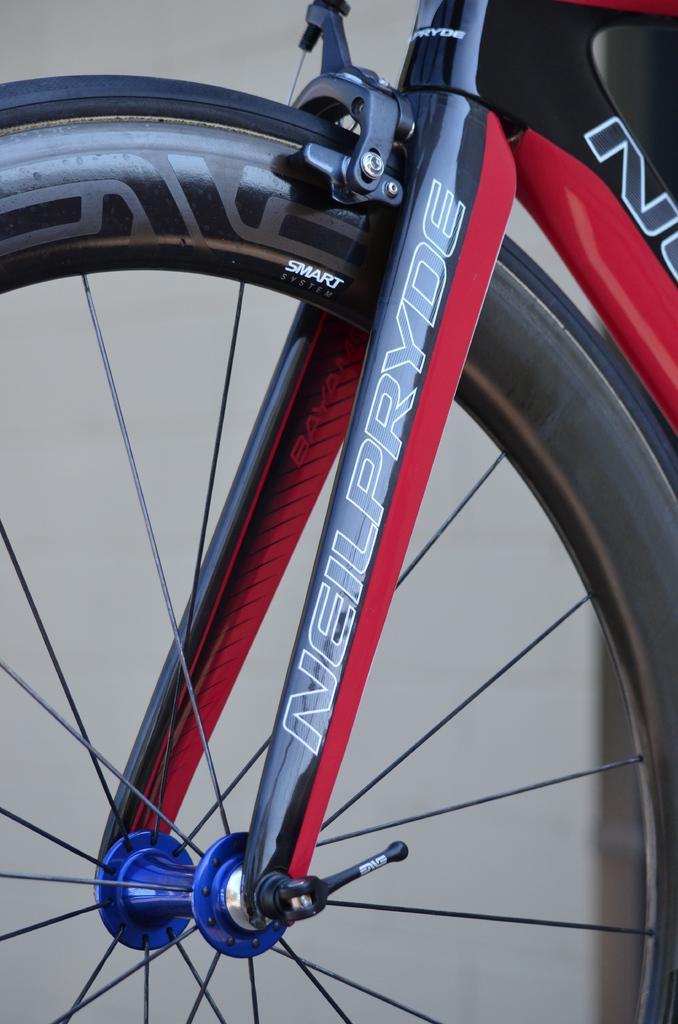Describe this image in one or two sentences. This is a truncated bicycle. Here we can see a bicycle wheel. In the background the image is blur. 